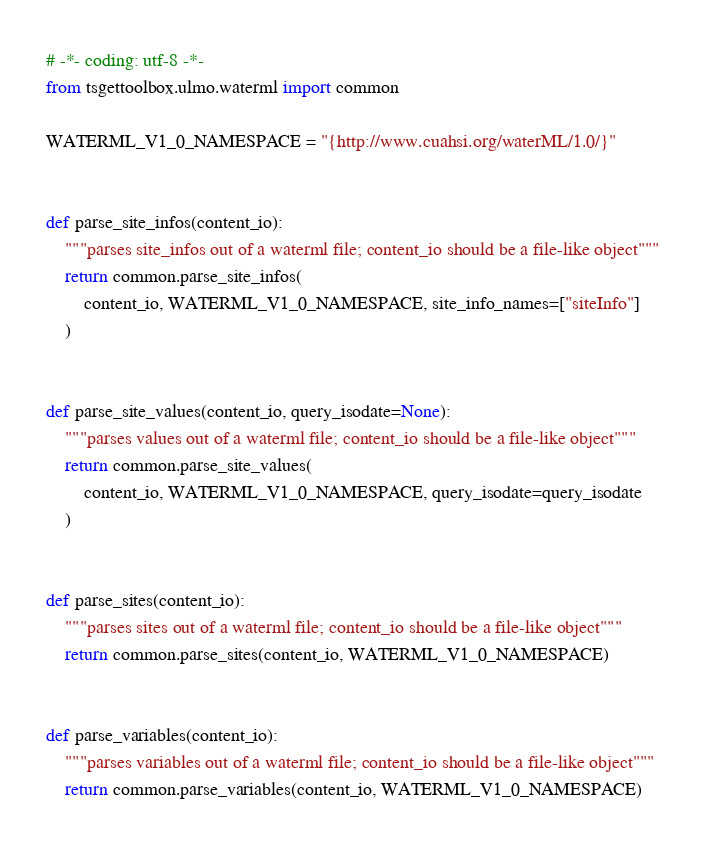<code> <loc_0><loc_0><loc_500><loc_500><_Python_># -*- coding: utf-8 -*-
from tsgettoolbox.ulmo.waterml import common

WATERML_V1_0_NAMESPACE = "{http://www.cuahsi.org/waterML/1.0/}"


def parse_site_infos(content_io):
    """parses site_infos out of a waterml file; content_io should be a file-like object"""
    return common.parse_site_infos(
        content_io, WATERML_V1_0_NAMESPACE, site_info_names=["siteInfo"]
    )


def parse_site_values(content_io, query_isodate=None):
    """parses values out of a waterml file; content_io should be a file-like object"""
    return common.parse_site_values(
        content_io, WATERML_V1_0_NAMESPACE, query_isodate=query_isodate
    )


def parse_sites(content_io):
    """parses sites out of a waterml file; content_io should be a file-like object"""
    return common.parse_sites(content_io, WATERML_V1_0_NAMESPACE)


def parse_variables(content_io):
    """parses variables out of a waterml file; content_io should be a file-like object"""
    return common.parse_variables(content_io, WATERML_V1_0_NAMESPACE)
</code> 